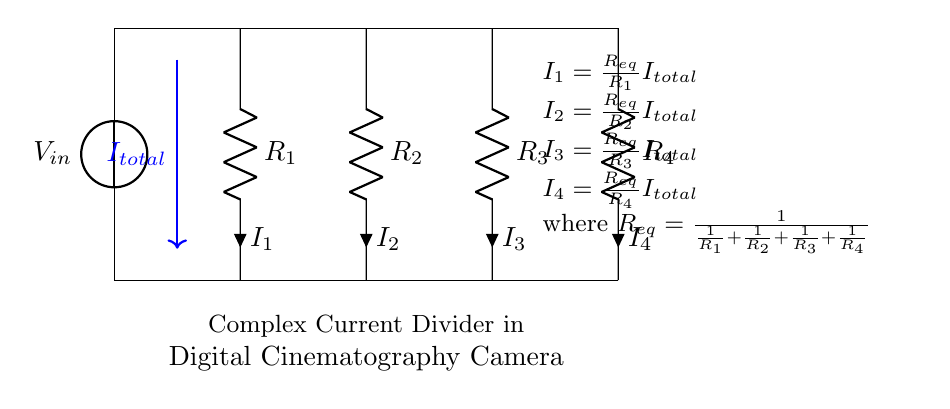What is the total current entering the circuit? The total current entering the circuit is represented as I total, which is the current flowing from the voltage source and is indicated by the arrow pointing downwards in the circuit diagram.
Answer: I total How many resistors are present in the circuit? The circuit diagram features a total of four resistors, labeled R1, R2, R3, and R4.
Answer: Four What is the equivalent resistance formula in this circuit? The equivalent resistance formula given in the diagram is R eq equals the reciprocal of the sum of the reciprocals of each resistor: one over the sum of one over R1, R2, R3, and R4.
Answer: R eq = 1/(1/R1 + 1/R2 + 1/R3 + 1/R4) Which resistor has the highest current flowing through it? To determine which resistor has the highest current, one would need to compare the currents I1, I2, I3, and I4, given that a lower resistance leads to a higher current in a parallel circuit, and identify the resistor with the highest corresponding current.
Answer: Depends on the resistor values If R1 = 2 ohms, R2 = 4 ohms, R3 = 8 ohms, and R4 = 16 ohms, what is the equivalent resistance? To calculate the equivalent resistance, use the formula R eq = 1/(1/R1 + 1/R2 + 1/R3 + 1/R4). First, calculate each reciprocal: 1/2 + 1/4 + 1/8 + 1/16, which equals 0.875, thus R eq equals approximately 1.14 ohms.
Answer: Approximately 1.14 ohms What is the current through R3 if the total current is 10A? Using the current divider equation, I3 can be calculated as (R eq/R3) multiplied by I total. By substituting the values for R eq previously calculated and R3 into the equation, the current through R3 can be determined.
Answer: Depends on the values used for calculation 